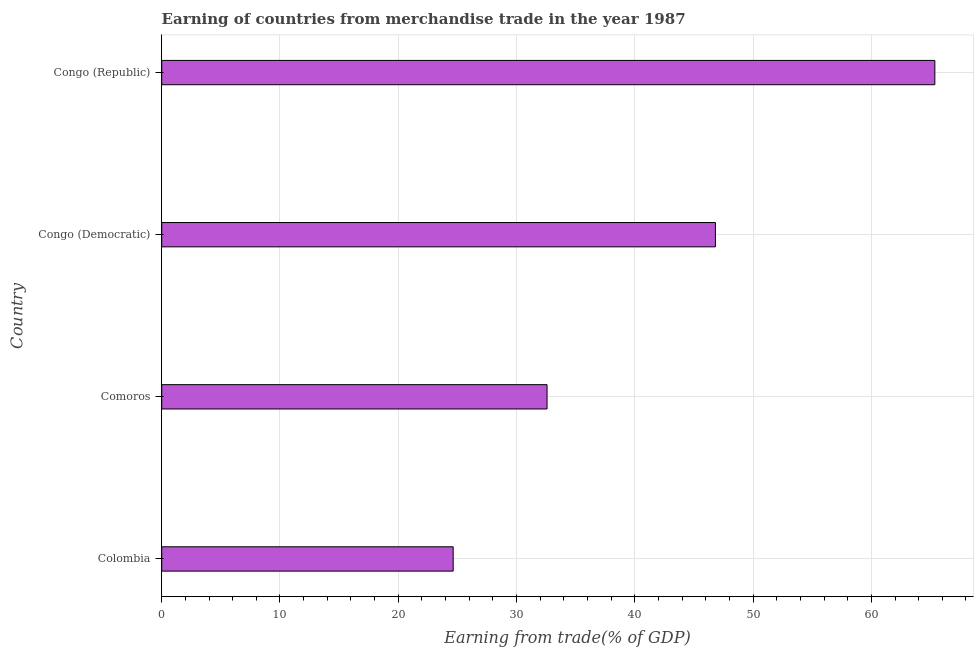Does the graph contain any zero values?
Make the answer very short. No. Does the graph contain grids?
Keep it short and to the point. Yes. What is the title of the graph?
Offer a very short reply. Earning of countries from merchandise trade in the year 1987. What is the label or title of the X-axis?
Offer a terse response. Earning from trade(% of GDP). What is the earning from merchandise trade in Congo (Democratic)?
Offer a very short reply. 46.82. Across all countries, what is the maximum earning from merchandise trade?
Keep it short and to the point. 65.37. Across all countries, what is the minimum earning from merchandise trade?
Provide a succinct answer. 24.64. In which country was the earning from merchandise trade maximum?
Offer a terse response. Congo (Republic). In which country was the earning from merchandise trade minimum?
Your response must be concise. Colombia. What is the sum of the earning from merchandise trade?
Your answer should be compact. 169.41. What is the difference between the earning from merchandise trade in Colombia and Comoros?
Provide a short and direct response. -7.94. What is the average earning from merchandise trade per country?
Offer a very short reply. 42.35. What is the median earning from merchandise trade?
Your response must be concise. 39.7. What is the ratio of the earning from merchandise trade in Colombia to that in Comoros?
Provide a short and direct response. 0.76. Is the earning from merchandise trade in Colombia less than that in Congo (Democratic)?
Offer a very short reply. Yes. Is the difference between the earning from merchandise trade in Comoros and Congo (Democratic) greater than the difference between any two countries?
Offer a terse response. No. What is the difference between the highest and the second highest earning from merchandise trade?
Provide a succinct answer. 18.55. What is the difference between the highest and the lowest earning from merchandise trade?
Your answer should be very brief. 40.72. In how many countries, is the earning from merchandise trade greater than the average earning from merchandise trade taken over all countries?
Ensure brevity in your answer.  2. How many bars are there?
Provide a short and direct response. 4. Are all the bars in the graph horizontal?
Your response must be concise. Yes. What is the difference between two consecutive major ticks on the X-axis?
Make the answer very short. 10. Are the values on the major ticks of X-axis written in scientific E-notation?
Ensure brevity in your answer.  No. What is the Earning from trade(% of GDP) in Colombia?
Your response must be concise. 24.64. What is the Earning from trade(% of GDP) of Comoros?
Give a very brief answer. 32.58. What is the Earning from trade(% of GDP) in Congo (Democratic)?
Keep it short and to the point. 46.82. What is the Earning from trade(% of GDP) in Congo (Republic)?
Your response must be concise. 65.37. What is the difference between the Earning from trade(% of GDP) in Colombia and Comoros?
Offer a very short reply. -7.94. What is the difference between the Earning from trade(% of GDP) in Colombia and Congo (Democratic)?
Keep it short and to the point. -22.17. What is the difference between the Earning from trade(% of GDP) in Colombia and Congo (Republic)?
Ensure brevity in your answer.  -40.72. What is the difference between the Earning from trade(% of GDP) in Comoros and Congo (Democratic)?
Give a very brief answer. -14.24. What is the difference between the Earning from trade(% of GDP) in Comoros and Congo (Republic)?
Make the answer very short. -32.79. What is the difference between the Earning from trade(% of GDP) in Congo (Democratic) and Congo (Republic)?
Provide a short and direct response. -18.55. What is the ratio of the Earning from trade(% of GDP) in Colombia to that in Comoros?
Offer a very short reply. 0.76. What is the ratio of the Earning from trade(% of GDP) in Colombia to that in Congo (Democratic)?
Keep it short and to the point. 0.53. What is the ratio of the Earning from trade(% of GDP) in Colombia to that in Congo (Republic)?
Offer a very short reply. 0.38. What is the ratio of the Earning from trade(% of GDP) in Comoros to that in Congo (Democratic)?
Provide a succinct answer. 0.7. What is the ratio of the Earning from trade(% of GDP) in Comoros to that in Congo (Republic)?
Make the answer very short. 0.5. What is the ratio of the Earning from trade(% of GDP) in Congo (Democratic) to that in Congo (Republic)?
Your answer should be very brief. 0.72. 